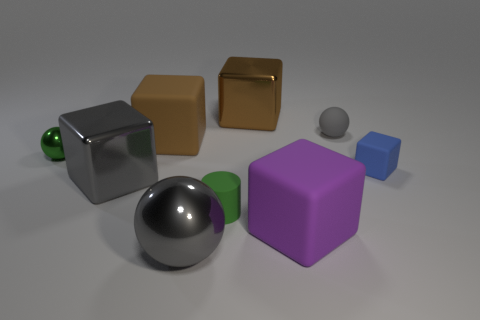Do the metallic cube that is to the left of the big gray sphere and the rubber ball have the same color?
Offer a very short reply. Yes. What is the size of the brown rubber cube?
Ensure brevity in your answer.  Large. There is a big rubber thing that is to the right of the large metallic block that is behind the blue cube; is there a tiny blue rubber thing that is to the left of it?
Your answer should be compact. No. There is a tiny rubber cube; what number of gray matte spheres are behind it?
Keep it short and to the point. 1. How many large metal objects have the same color as the rubber ball?
Offer a terse response. 2. How many things are cubes to the right of the gray cube or gray things that are behind the large brown rubber object?
Your answer should be compact. 5. Is the number of rubber balls greater than the number of brown cubes?
Make the answer very short. No. What color is the metal block that is in front of the tiny gray rubber sphere?
Keep it short and to the point. Gray. Do the small shiny thing and the large purple rubber thing have the same shape?
Your answer should be very brief. No. What is the color of the sphere that is behind the large metallic sphere and on the left side of the small green cylinder?
Keep it short and to the point. Green. 